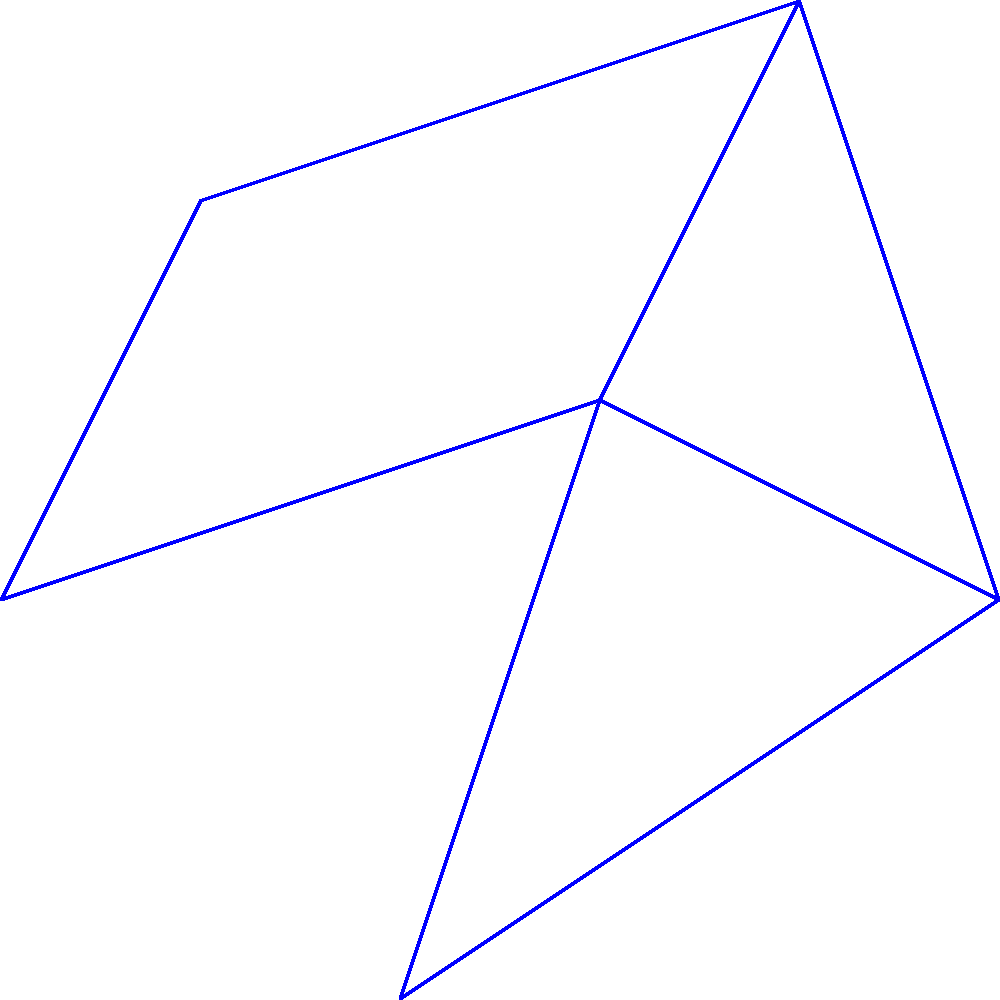As a Swiss sports enthusiast, you're planning a skiing trip through various resorts. The map above shows ski resorts (R1 to R6) connected by trails, with the numbers representing travel time in hours. What's the shortest time to travel from resort R1 to R6? To find the shortest path from R1 to R6, we'll use Dijkstra's algorithm:

1. Initialize:
   - R1: 0 (starting point)
   - All other resorts: infinity

2. From R1:
   - R2: 5 hours
   - R3: 3 hours

3. From R3 (shortest unvisited):
   - R4: 3 + 4 = 7 hours
   - R5: 3 + 6 = 9 hours
   - R6: 3 + 7 = 10 hours

4. From R2:
   - R4: min(7, 5 + 2) = 7 hours (no change)

5. From R4:
   - R5: min(9, 7 + 1) = 8 hours

6. From R5:
   - R6: min(10, 8 + 2) = 10 hours (no change)

The shortest path is R1 -> R3 -> R5 -> R6, taking 10 hours.
Answer: 10 hours 